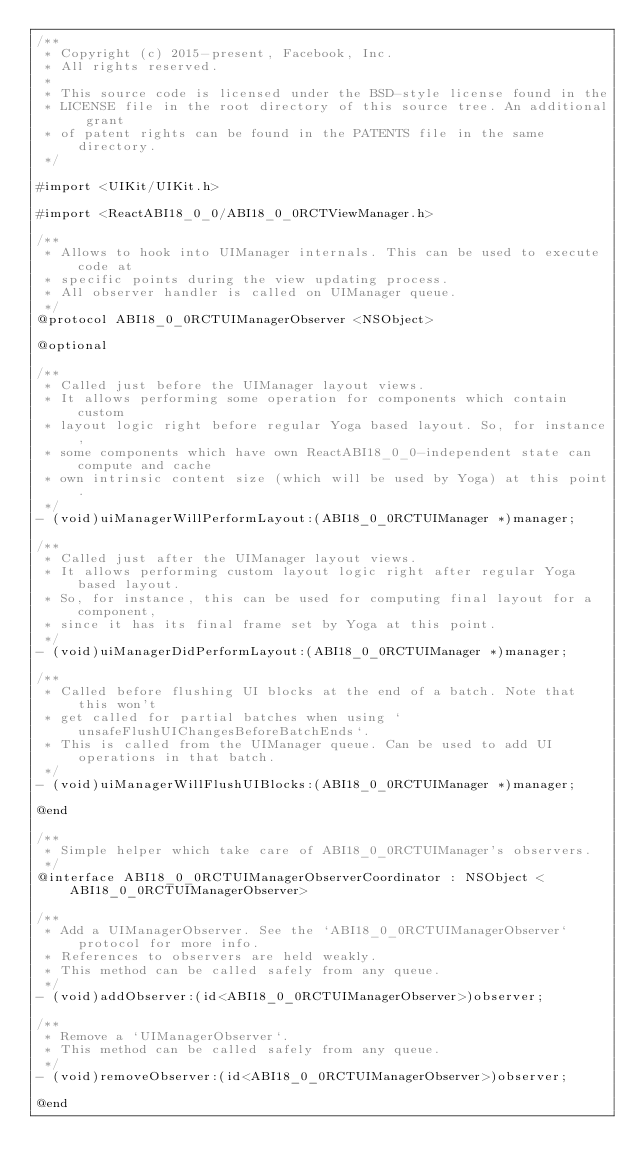Convert code to text. <code><loc_0><loc_0><loc_500><loc_500><_C_>/**
 * Copyright (c) 2015-present, Facebook, Inc.
 * All rights reserved.
 *
 * This source code is licensed under the BSD-style license found in the
 * LICENSE file in the root directory of this source tree. An additional grant
 * of patent rights can be found in the PATENTS file in the same directory.
 */

#import <UIKit/UIKit.h>

#import <ReactABI18_0_0/ABI18_0_0RCTViewManager.h>

/**
 * Allows to hook into UIManager internals. This can be used to execute code at
 * specific points during the view updating process.
 * All observer handler is called on UIManager queue.
 */
@protocol ABI18_0_0RCTUIManagerObserver <NSObject>

@optional

/**
 * Called just before the UIManager layout views.
 * It allows performing some operation for components which contain custom
 * layout logic right before regular Yoga based layout. So, for instance,
 * some components which have own ReactABI18_0_0-independent state can compute and cache
 * own intrinsic content size (which will be used by Yoga) at this point.
 */
- (void)uiManagerWillPerformLayout:(ABI18_0_0RCTUIManager *)manager;

/**
 * Called just after the UIManager layout views.
 * It allows performing custom layout logic right after regular Yoga based layout.
 * So, for instance, this can be used for computing final layout for a component,
 * since it has its final frame set by Yoga at this point.
 */
- (void)uiManagerDidPerformLayout:(ABI18_0_0RCTUIManager *)manager;

/**
 * Called before flushing UI blocks at the end of a batch. Note that this won't
 * get called for partial batches when using `unsafeFlushUIChangesBeforeBatchEnds`.
 * This is called from the UIManager queue. Can be used to add UI operations in that batch.
 */
- (void)uiManagerWillFlushUIBlocks:(ABI18_0_0RCTUIManager *)manager;

@end

/**
 * Simple helper which take care of ABI18_0_0RCTUIManager's observers.
 */
@interface ABI18_0_0RCTUIManagerObserverCoordinator : NSObject <ABI18_0_0RCTUIManagerObserver>

/**
 * Add a UIManagerObserver. See the `ABI18_0_0RCTUIManagerObserver` protocol for more info.
 * References to observers are held weakly.
 * This method can be called safely from any queue.
 */
- (void)addObserver:(id<ABI18_0_0RCTUIManagerObserver>)observer;

/**
 * Remove a `UIManagerObserver`.
 * This method can be called safely from any queue.
 */
- (void)removeObserver:(id<ABI18_0_0RCTUIManagerObserver>)observer;

@end
</code> 